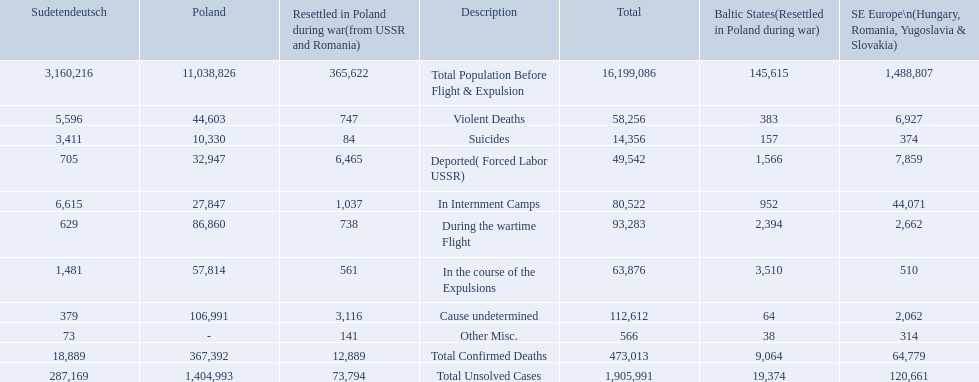How many deaths did the baltic states have in each category? 145,615, 383, 157, 1,566, 952, 2,394, 3,510, 64, 38, 9,064, 19,374. How many cause undetermined deaths did baltic states have? 64. How many other miscellaneous deaths did baltic states have? 38. Which is higher in deaths, cause undetermined or other miscellaneous? Cause undetermined. 